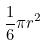Convert formula to latex. <formula><loc_0><loc_0><loc_500><loc_500>\frac { 1 } { 6 } \pi r ^ { 2 }</formula> 